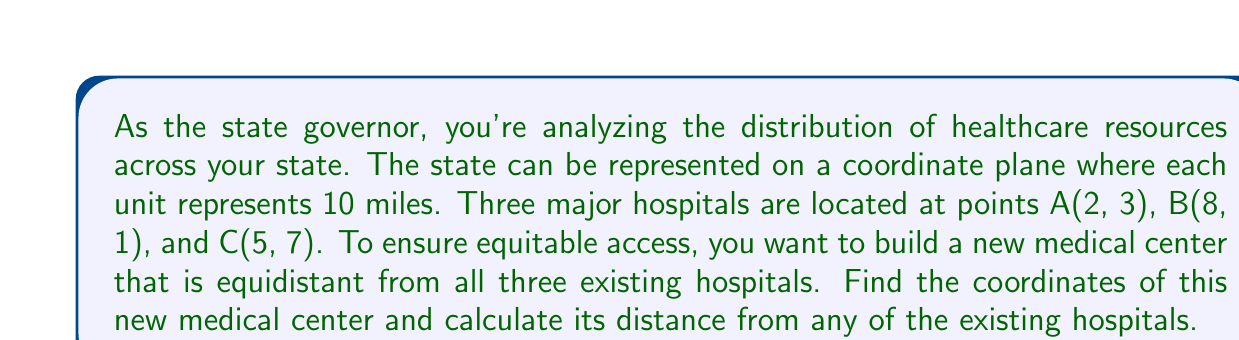Teach me how to tackle this problem. To solve this problem, we need to find the circumcenter of the triangle formed by the three hospitals. The circumcenter is equidistant from all three vertices and can be found by intersecting the perpendicular bisectors of the triangle's sides.

Step 1: Find the midpoints of the triangle's sides.
Midpoint of AB: $(\frac{2+8}{2}, \frac{3+1}{2}) = (5, 2)$
Midpoint of BC: $(\frac{8+5}{2}, \frac{1+7}{2}) = (6.5, 4)$
Midpoint of AC: $(\frac{2+5}{2}, \frac{3+7}{2}) = (3.5, 5)$

Step 2: Calculate the slopes of the triangle's sides.
Slope of AB: $m_{AB} = \frac{1-3}{8-2} = -\frac{1}{3}$
Slope of BC: $m_{BC} = \frac{7-1}{5-8} = -2$
Slope of AC: $m_{AC} = \frac{7-3}{5-2} = \frac{4}{3}$

Step 3: Calculate the slopes of the perpendicular bisectors.
Slope of AB's perpendicular bisector: $m_{AB\perp} = 3$
Slope of BC's perpendicular bisector: $m_{BC\perp} = \frac{1}{2}$

Step 4: Write equations for two perpendicular bisectors.
AB's perpendicular bisector: $y - 2 = 3(x - 5)$
BC's perpendicular bisector: $y - 4 = \frac{1}{2}(x - 6.5)$

Step 5: Solve the system of equations to find the intersection point (circumcenter).
$$\begin{cases}
y = 3x - 13 \\
y = \frac{1}{2}x + 0.75
\end{cases}$$

Solving this system:
$3x - 13 = \frac{1}{2}x + 0.75$
$\frac{5}{2}x = 13.75$
$x = 5.5$

Substituting back:
$y = 3(5.5) - 13 = 3.5$

Therefore, the coordinates of the new medical center are (5.5, 3.5).

Step 6: Calculate the distance from the new medical center to any of the existing hospitals using the distance formula.
Distance to hospital A:
$$d = \sqrt{(5.5-2)^2 + (3.5-3)^2} = \sqrt{3.5^2 + 0.5^2} = \sqrt{12.5} = 3.54$$

Converting to miles: $3.54 * 10 = 35.4$ miles
Answer: The coordinates of the new medical center are (5.5, 3.5), and it is approximately 35.4 miles from each of the existing hospitals. 